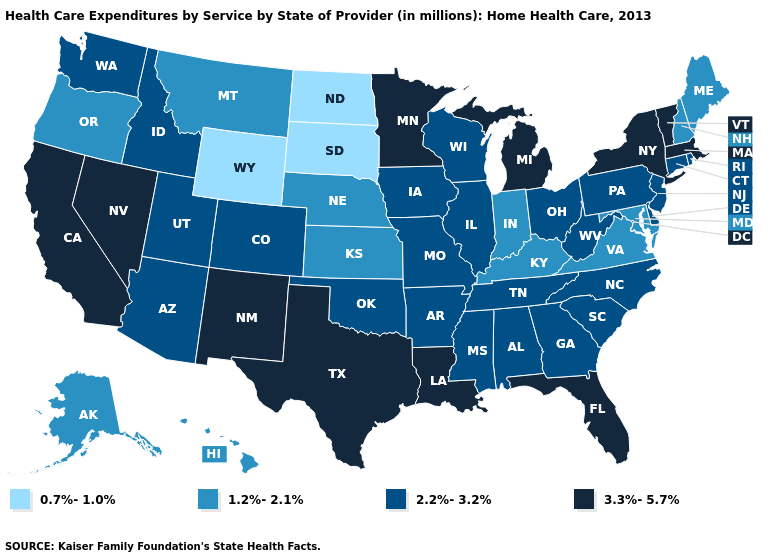Does South Dakota have the lowest value in the USA?
Be succinct. Yes. Does the first symbol in the legend represent the smallest category?
Quick response, please. Yes. What is the value of Oregon?
Quick response, please. 1.2%-2.1%. Among the states that border California , which have the highest value?
Be succinct. Nevada. What is the lowest value in the USA?
Quick response, please. 0.7%-1.0%. What is the value of West Virginia?
Keep it brief. 2.2%-3.2%. Name the states that have a value in the range 2.2%-3.2%?
Quick response, please. Alabama, Arizona, Arkansas, Colorado, Connecticut, Delaware, Georgia, Idaho, Illinois, Iowa, Mississippi, Missouri, New Jersey, North Carolina, Ohio, Oklahoma, Pennsylvania, Rhode Island, South Carolina, Tennessee, Utah, Washington, West Virginia, Wisconsin. What is the lowest value in the South?
Keep it brief. 1.2%-2.1%. How many symbols are there in the legend?
Write a very short answer. 4. Which states hav the highest value in the South?
Concise answer only. Florida, Louisiana, Texas. Does Minnesota have the highest value in the MidWest?
Concise answer only. Yes. What is the lowest value in the USA?
Concise answer only. 0.7%-1.0%. What is the value of Tennessee?
Keep it brief. 2.2%-3.2%. What is the value of Michigan?
Write a very short answer. 3.3%-5.7%. Is the legend a continuous bar?
Be succinct. No. 